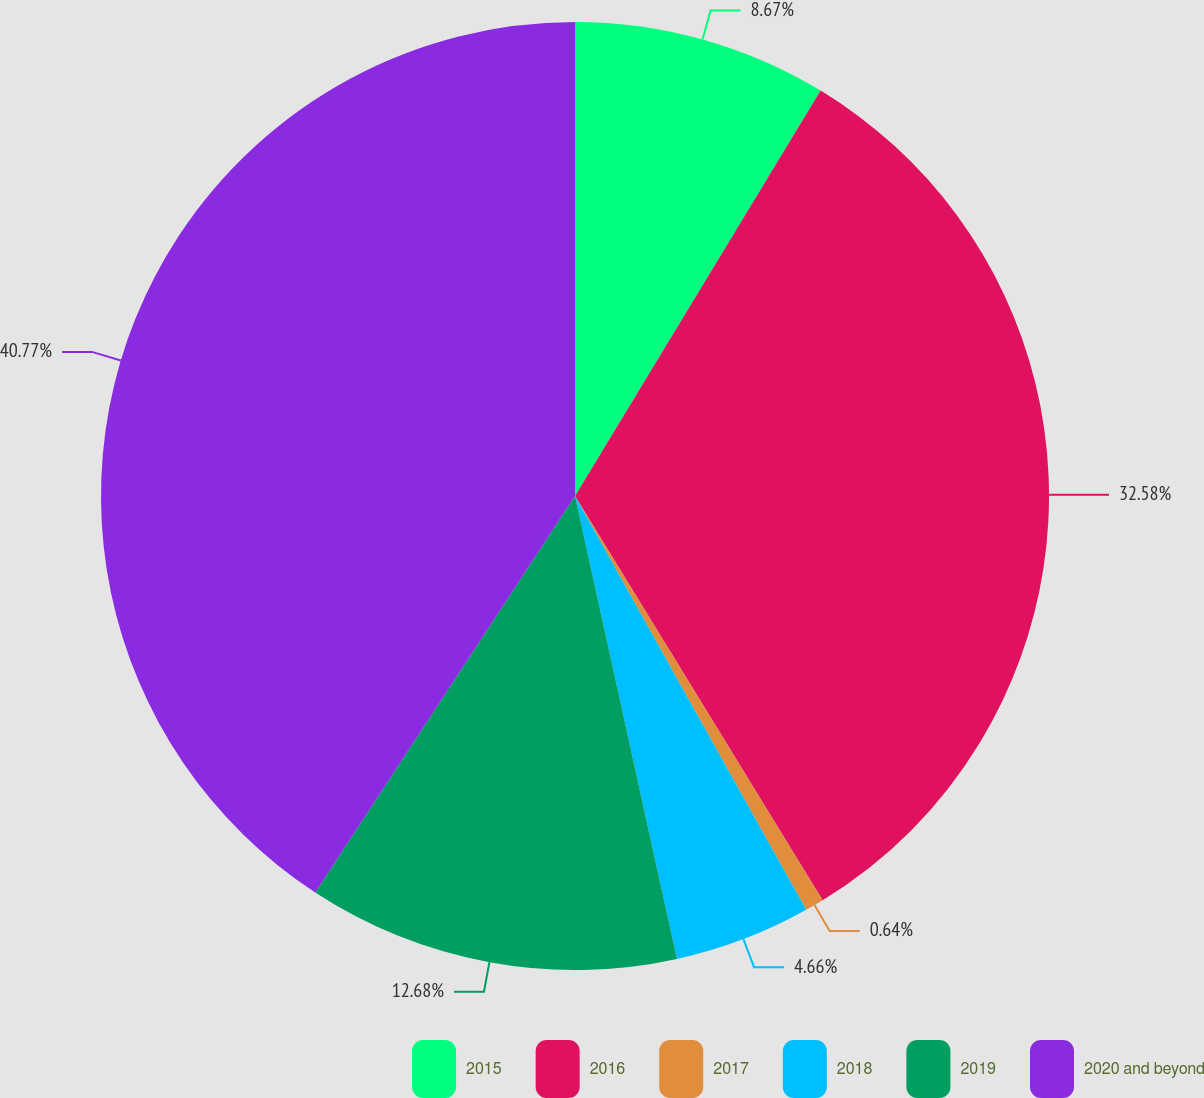Convert chart to OTSL. <chart><loc_0><loc_0><loc_500><loc_500><pie_chart><fcel>2015<fcel>2016<fcel>2017<fcel>2018<fcel>2019<fcel>2020 and beyond<nl><fcel>8.67%<fcel>32.58%<fcel>0.64%<fcel>4.66%<fcel>12.68%<fcel>40.77%<nl></chart> 